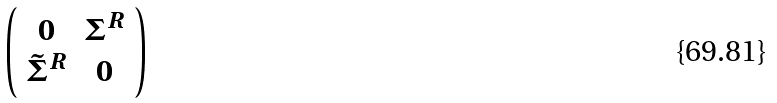<formula> <loc_0><loc_0><loc_500><loc_500>\left ( \begin{array} { c c } { 0 } & { { \Sigma ^ { R } } } \\ { { \tilde { \Sigma } ^ { R } } } & { 0 } \end{array} \right )</formula> 